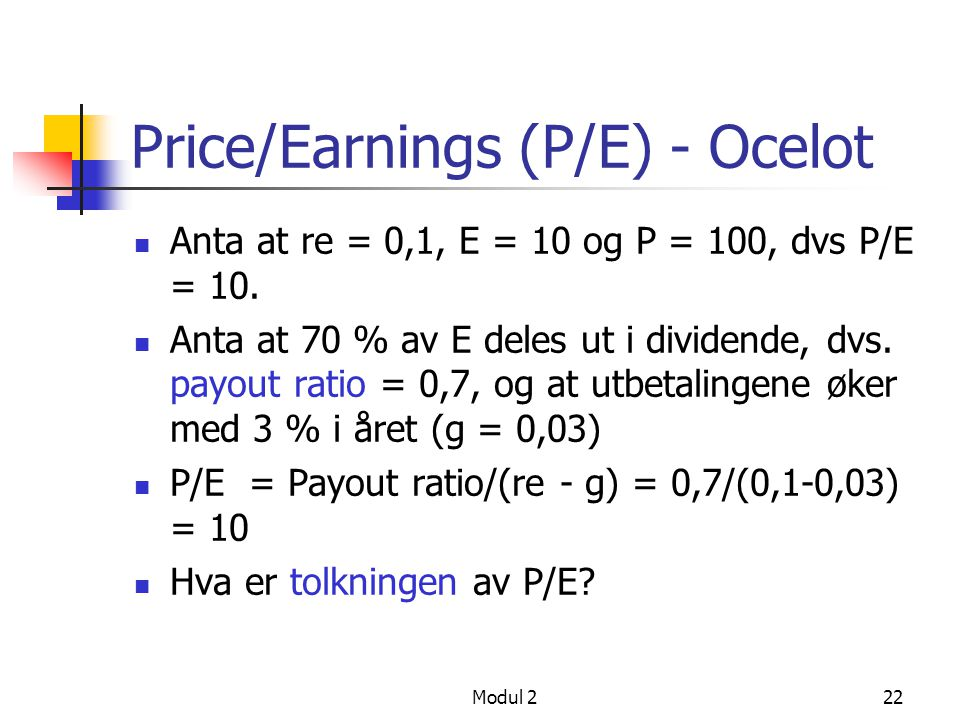If a company has a stable P/E ratio over many years, what might this indicate about its performance? A stable P/E ratio over many years typically indicates that a company has consistent earnings relative to its stock price. This consistency can signal reliable and predictable performance, which might be attractive to risk-averse investors. Stable P/E ratios suggest that the company operates in a stable industry with steady growth prospects and minimal fluctuations in earnings or market sentiment. 